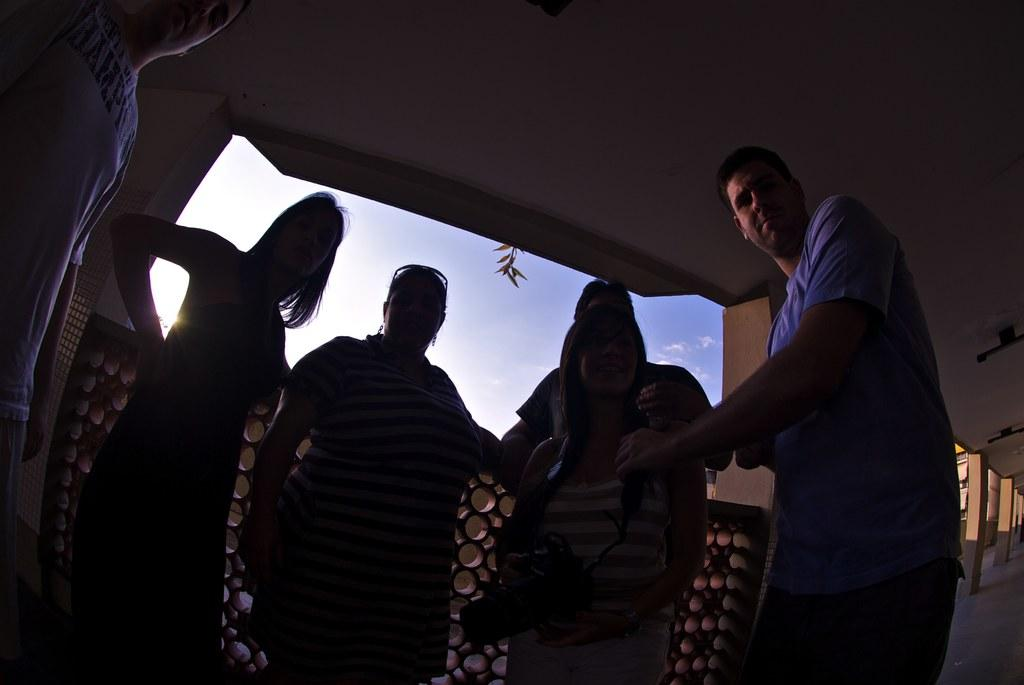How many people are in the group visible in the image? There is a group of people in the image, but the exact number is not specified. What architectural features can be seen in the background of the image? There are pillars and a roof visible in the background of the image. What part of the natural environment is visible in the image? The sky is visible in the background of the image. Can you describe the unspecified objects in the background of the image? Unfortunately, the facts provided do not give any details about the unspecified objects in the background. Can you see a giraffe in the image? No, there is no giraffe present in the image. 